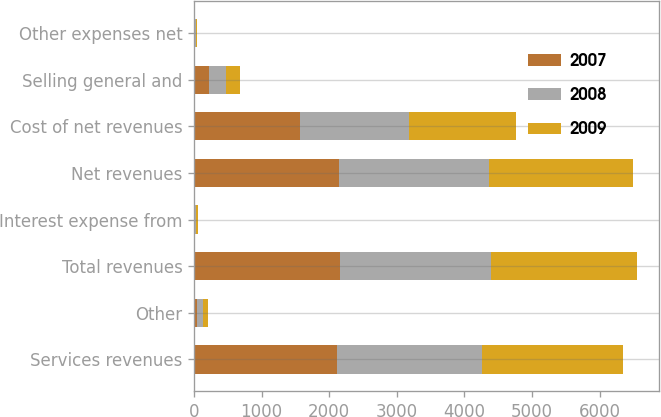Convert chart. <chart><loc_0><loc_0><loc_500><loc_500><stacked_bar_chart><ecel><fcel>Services revenues<fcel>Other<fcel>Total revenues<fcel>Interest expense from<fcel>Net revenues<fcel>Cost of net revenues<fcel>Selling general and<fcel>Other expenses net<nl><fcel>2007<fcel>2111.6<fcel>43.3<fcel>2154.9<fcel>5.6<fcel>2149.3<fcel>1574.1<fcel>224.9<fcel>4<nl><fcel>2008<fcel>2151.6<fcel>82.5<fcel>2234.1<fcel>26.6<fcel>2207.5<fcel>1606.4<fcel>244.3<fcel>30.9<nl><fcel>2009<fcel>2078.7<fcel>84<fcel>2162.7<fcel>24.8<fcel>2137.9<fcel>1588.1<fcel>216.7<fcel>12.3<nl></chart> 